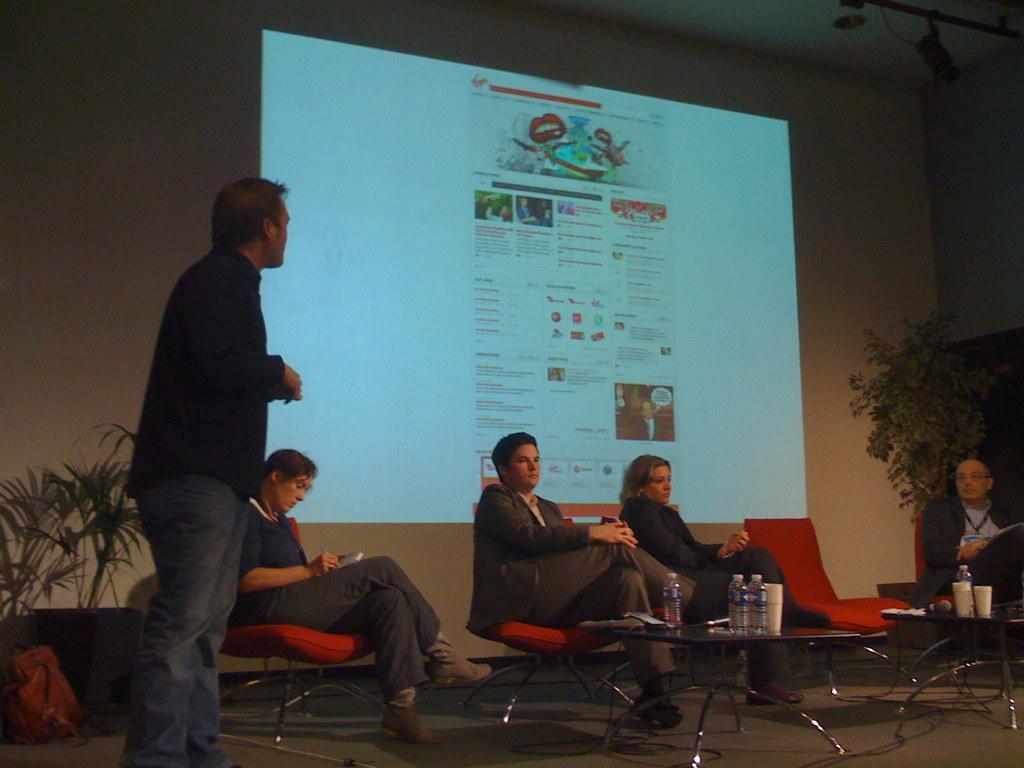How would you summarize this image in a sentence or two? In the image there are few men and women sat on chair in front of them there is a table with water bottles on it,this place seems to be on stage,there is projector screen on the background wall and there are plants on either sides of the image. 